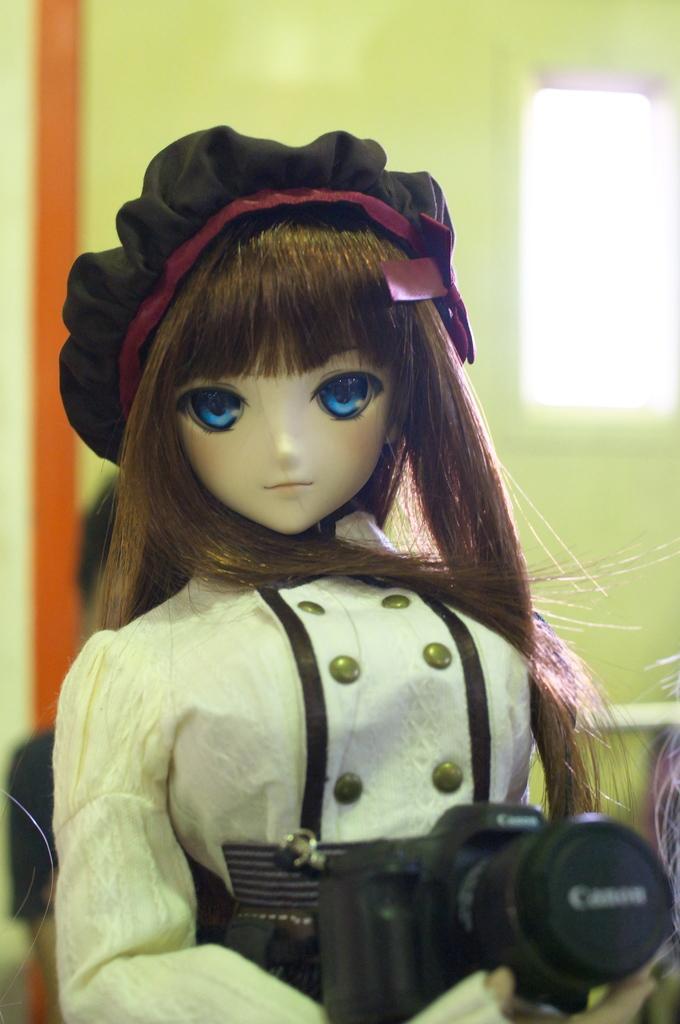Please provide a concise description of this image. In this image there is a doll holding a camera in her hand with a long hair and wearing a hat. At the background there is a wall and window. 